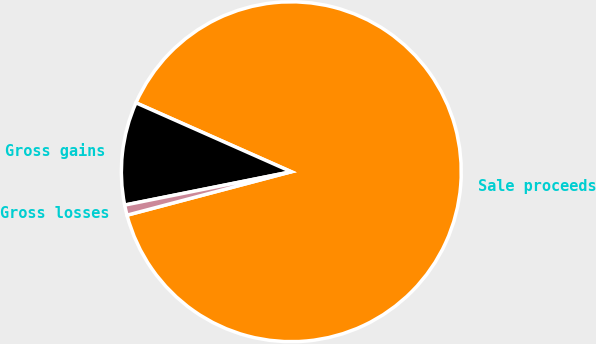Convert chart. <chart><loc_0><loc_0><loc_500><loc_500><pie_chart><fcel>Sale proceeds<fcel>Gross gains<fcel>Gross losses<nl><fcel>89.24%<fcel>9.79%<fcel>0.97%<nl></chart> 